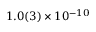<formula> <loc_0><loc_0><loc_500><loc_500>1 . 0 ( 3 ) \times 1 0 ^ { - 1 0 }</formula> 